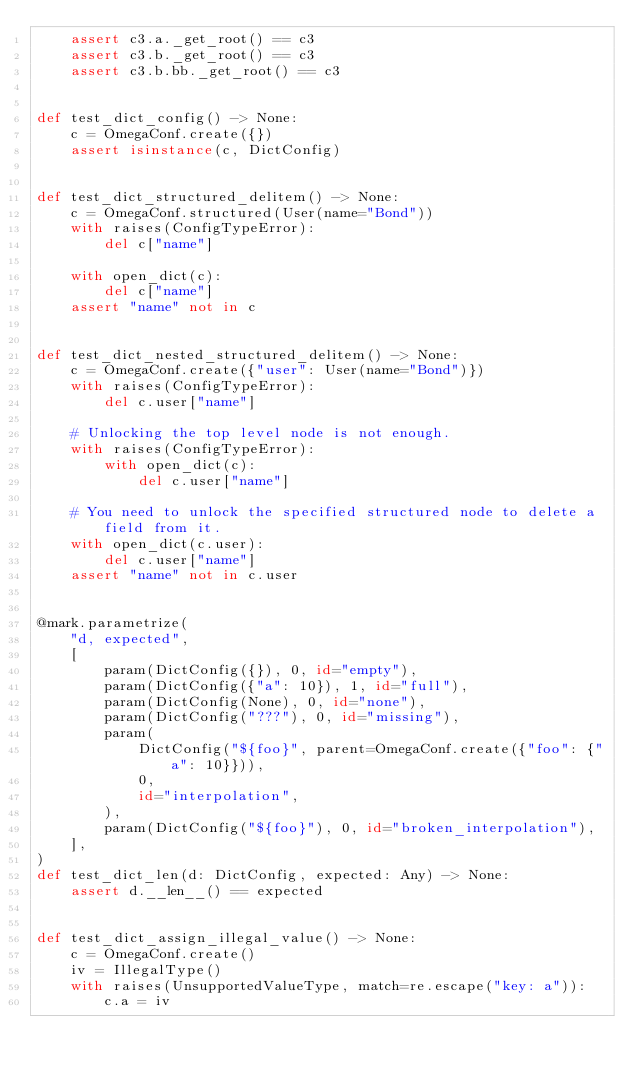Convert code to text. <code><loc_0><loc_0><loc_500><loc_500><_Python_>    assert c3.a._get_root() == c3
    assert c3.b._get_root() == c3
    assert c3.b.bb._get_root() == c3


def test_dict_config() -> None:
    c = OmegaConf.create({})
    assert isinstance(c, DictConfig)


def test_dict_structured_delitem() -> None:
    c = OmegaConf.structured(User(name="Bond"))
    with raises(ConfigTypeError):
        del c["name"]

    with open_dict(c):
        del c["name"]
    assert "name" not in c


def test_dict_nested_structured_delitem() -> None:
    c = OmegaConf.create({"user": User(name="Bond")})
    with raises(ConfigTypeError):
        del c.user["name"]

    # Unlocking the top level node is not enough.
    with raises(ConfigTypeError):
        with open_dict(c):
            del c.user["name"]

    # You need to unlock the specified structured node to delete a field from it.
    with open_dict(c.user):
        del c.user["name"]
    assert "name" not in c.user


@mark.parametrize(
    "d, expected",
    [
        param(DictConfig({}), 0, id="empty"),
        param(DictConfig({"a": 10}), 1, id="full"),
        param(DictConfig(None), 0, id="none"),
        param(DictConfig("???"), 0, id="missing"),
        param(
            DictConfig("${foo}", parent=OmegaConf.create({"foo": {"a": 10}})),
            0,
            id="interpolation",
        ),
        param(DictConfig("${foo}"), 0, id="broken_interpolation"),
    ],
)
def test_dict_len(d: DictConfig, expected: Any) -> None:
    assert d.__len__() == expected


def test_dict_assign_illegal_value() -> None:
    c = OmegaConf.create()
    iv = IllegalType()
    with raises(UnsupportedValueType, match=re.escape("key: a")):
        c.a = iv
</code> 